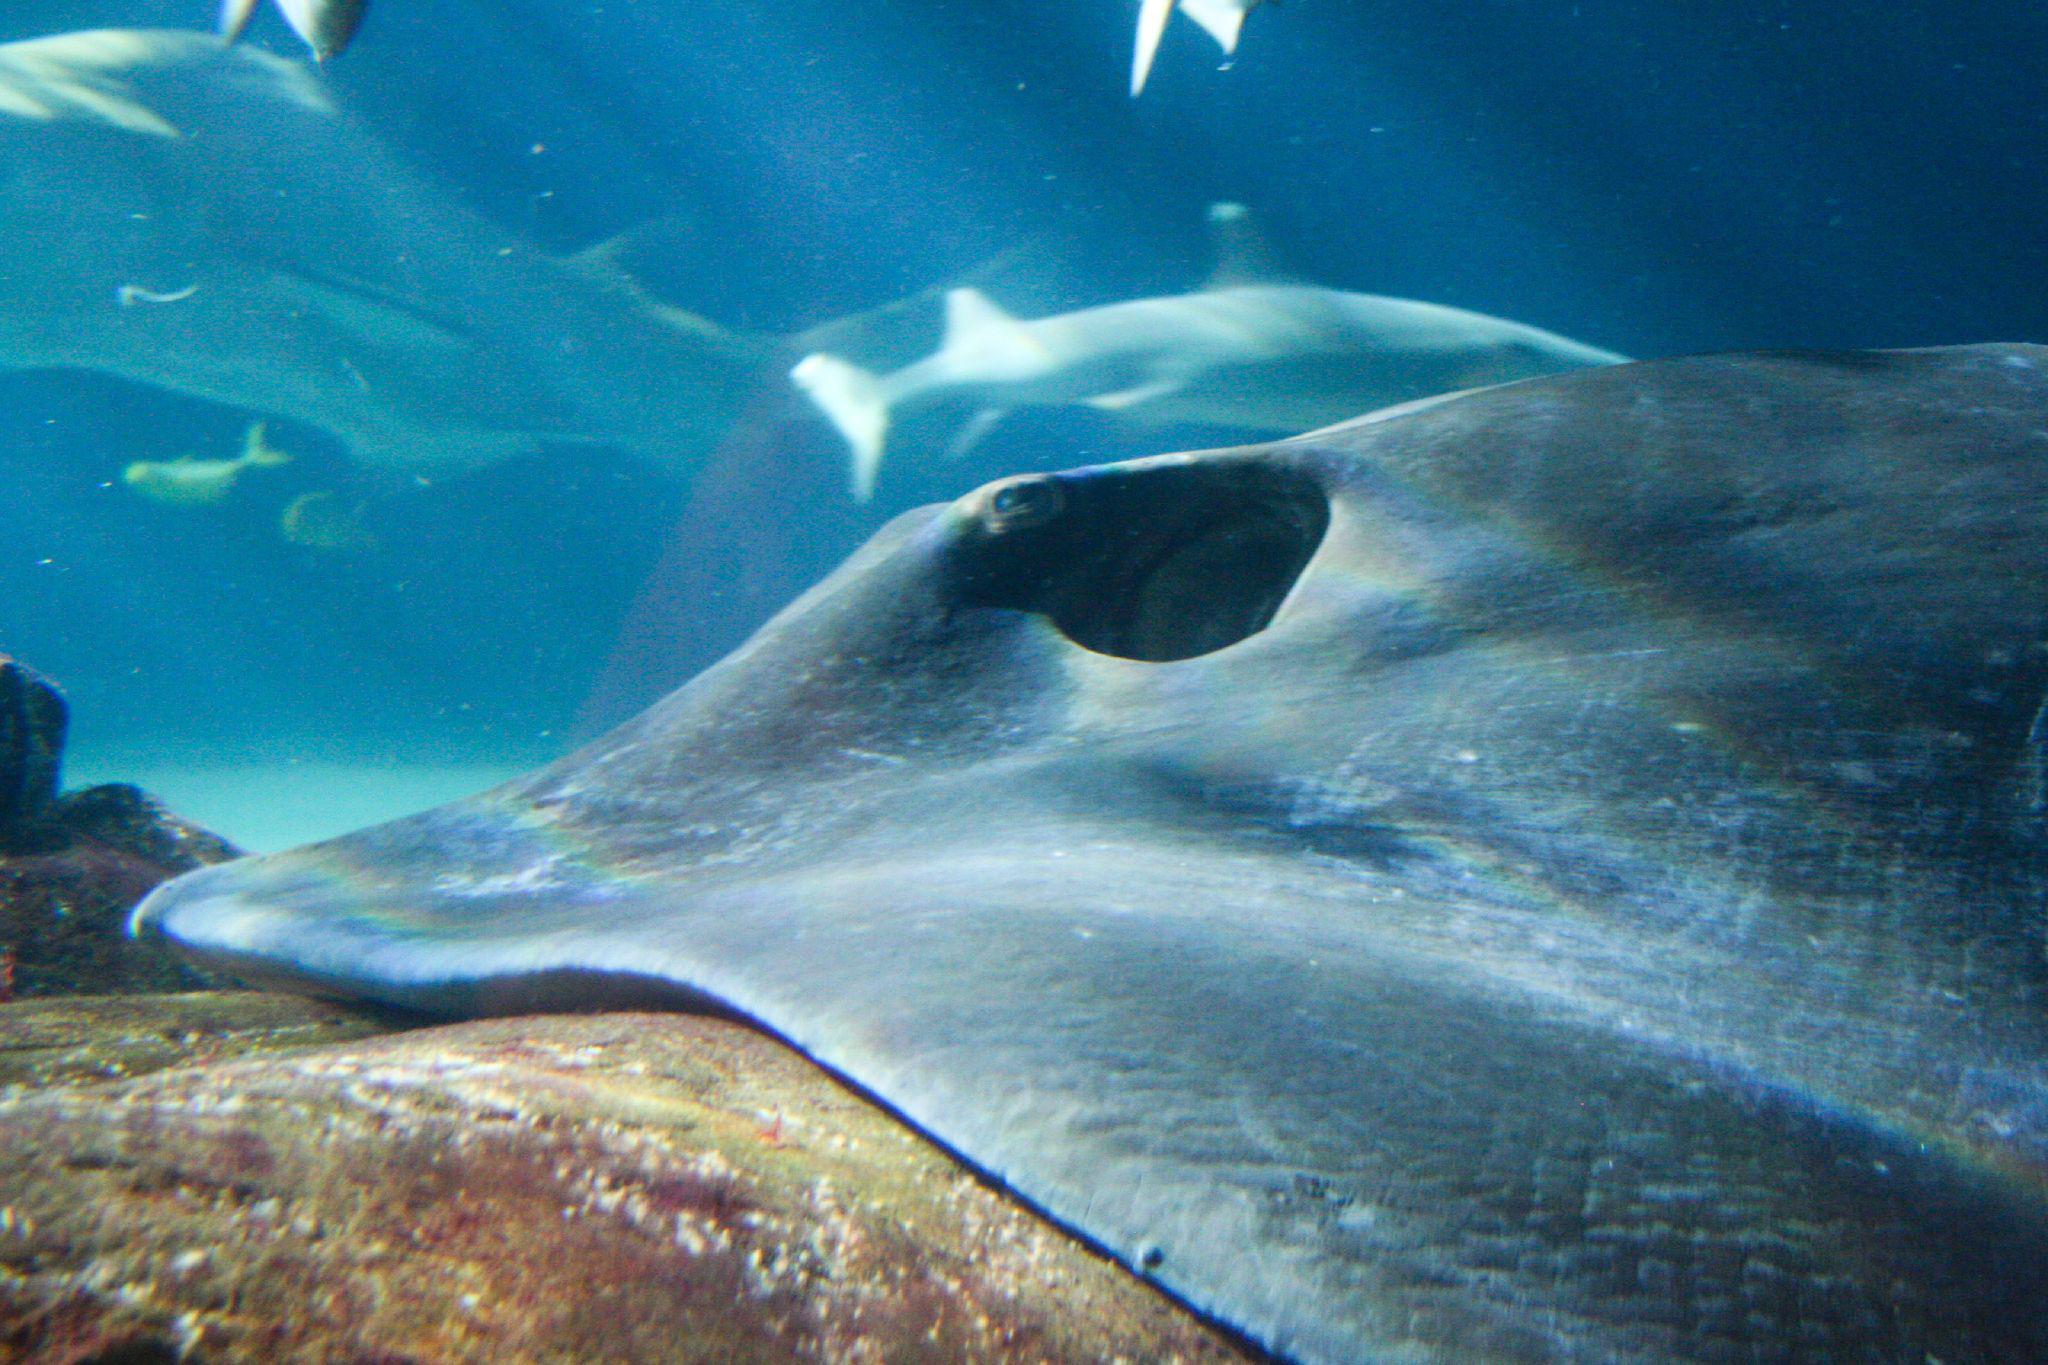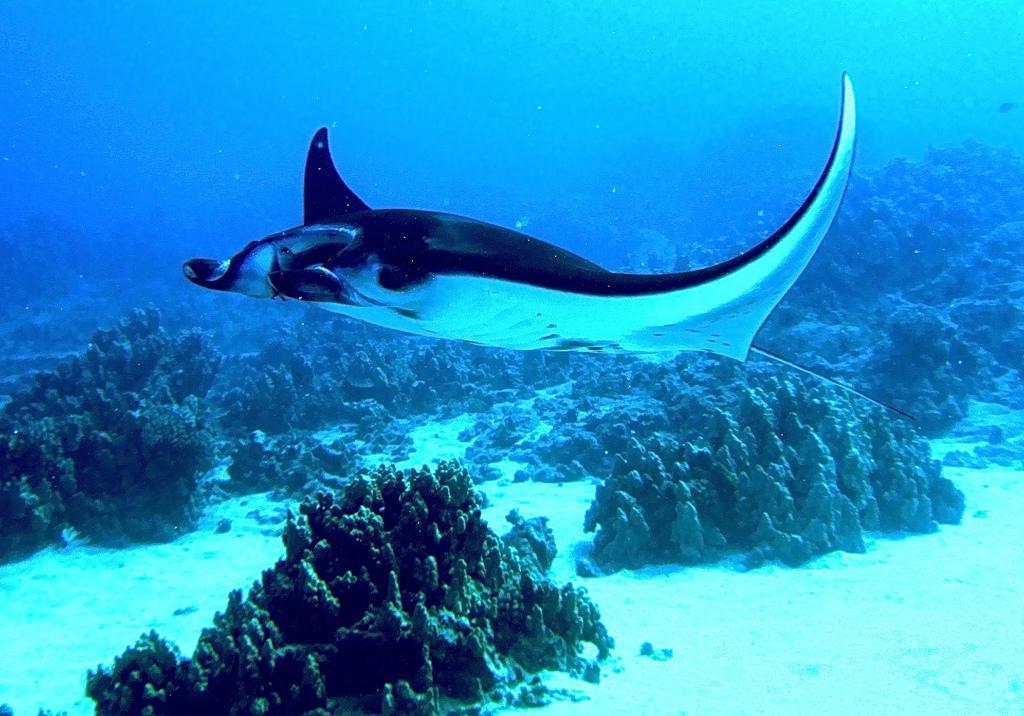The first image is the image on the left, the second image is the image on the right. Analyze the images presented: Is the assertion "There are two stingrays and no other creatures." valid? Answer yes or no. No. 